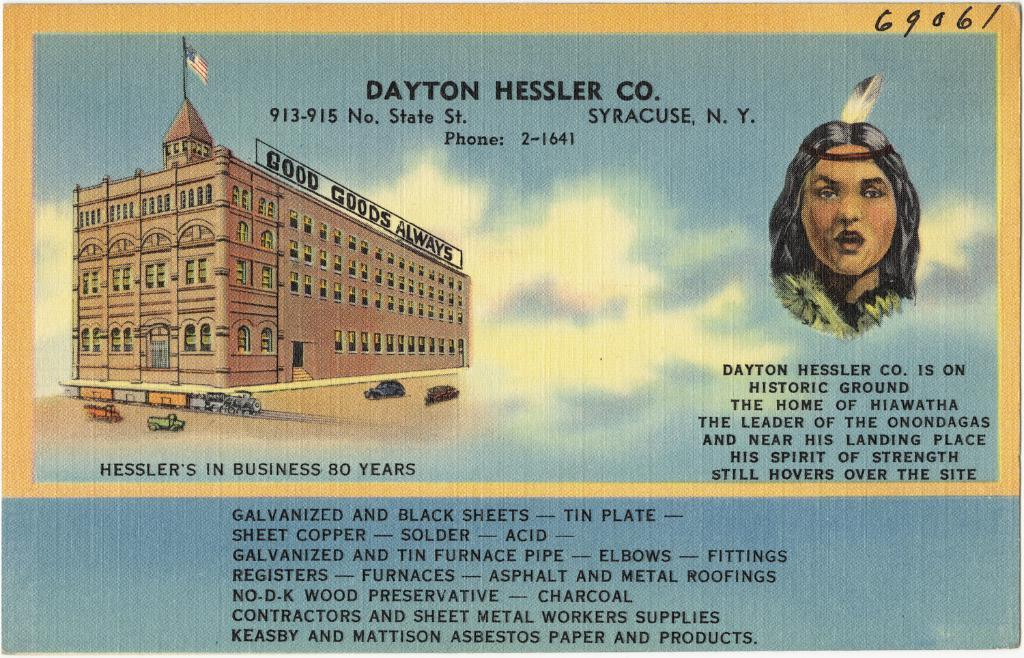What is written on the paper in the image? The image shows a paper with text, but the specific content is not mentioned. What can be seen on the left side of the image? There is a building on the left side of the image. Who is present on the right side of the image? There is a woman on the right side of the image. Reasoning: Let's think step by step by step in order to produce the conversation. We start by identifying the main subjects and objects in the image based on the provided facts. We then formulate questions that focus on the location and characteristics of these subjects and objects, ensuring that each question can be answered definitively with the information given. We avoid yes/no questions and ensure that the language is simple and clear. Absurd Question/Answer: What type of animals can be seen at the zoo in the image? There is no zoo present in the image; it features a paper with text, a building, and a woman. What statement does the sky make in the image? The sky is not making a statement in the image, as it is a natural element and not capable of making statements. 